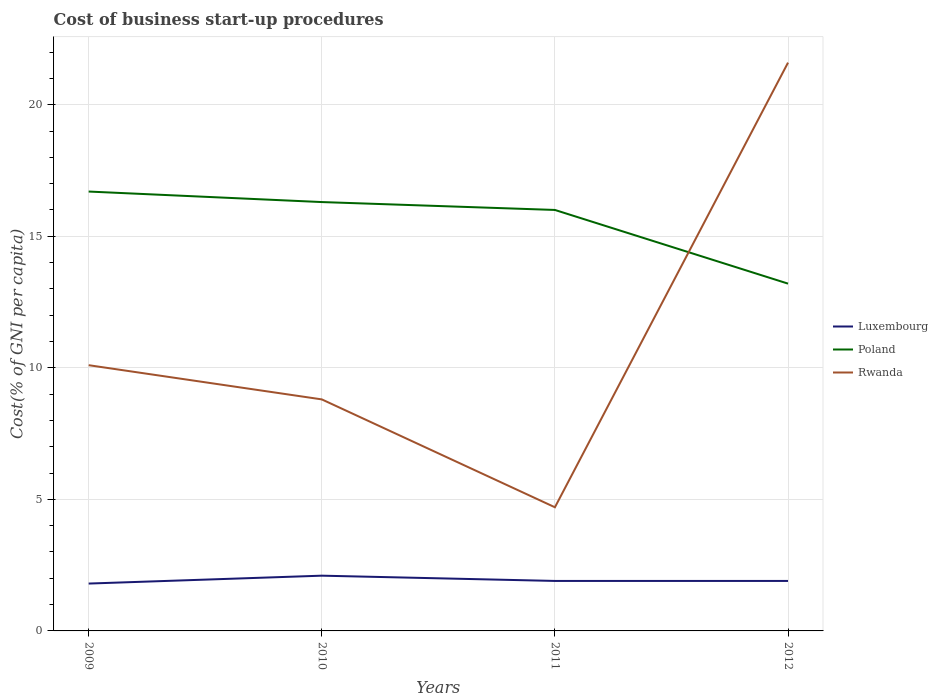How many different coloured lines are there?
Ensure brevity in your answer.  3. Is the number of lines equal to the number of legend labels?
Make the answer very short. Yes. What is the total cost of business start-up procedures in Luxembourg in the graph?
Keep it short and to the point. 0.2. What is the difference between the highest and the second highest cost of business start-up procedures in Luxembourg?
Your response must be concise. 0.3. What is the difference between the highest and the lowest cost of business start-up procedures in Poland?
Offer a terse response. 3. Is the cost of business start-up procedures in Rwanda strictly greater than the cost of business start-up procedures in Poland over the years?
Offer a very short reply. No. How many lines are there?
Give a very brief answer. 3. How many years are there in the graph?
Make the answer very short. 4. What is the difference between two consecutive major ticks on the Y-axis?
Provide a short and direct response. 5. Does the graph contain any zero values?
Offer a very short reply. No. Where does the legend appear in the graph?
Provide a succinct answer. Center right. How many legend labels are there?
Your response must be concise. 3. How are the legend labels stacked?
Keep it short and to the point. Vertical. What is the title of the graph?
Offer a very short reply. Cost of business start-up procedures. Does "Colombia" appear as one of the legend labels in the graph?
Offer a very short reply. No. What is the label or title of the X-axis?
Keep it short and to the point. Years. What is the label or title of the Y-axis?
Provide a succinct answer. Cost(% of GNI per capita). What is the Cost(% of GNI per capita) of Luxembourg in 2009?
Your answer should be very brief. 1.8. What is the Cost(% of GNI per capita) of Rwanda in 2009?
Offer a very short reply. 10.1. What is the Cost(% of GNI per capita) of Luxembourg in 2010?
Your answer should be very brief. 2.1. What is the Cost(% of GNI per capita) of Luxembourg in 2012?
Your answer should be very brief. 1.9. What is the Cost(% of GNI per capita) of Poland in 2012?
Your answer should be compact. 13.2. What is the Cost(% of GNI per capita) in Rwanda in 2012?
Keep it short and to the point. 21.6. Across all years, what is the maximum Cost(% of GNI per capita) in Rwanda?
Your answer should be compact. 21.6. Across all years, what is the minimum Cost(% of GNI per capita) in Rwanda?
Ensure brevity in your answer.  4.7. What is the total Cost(% of GNI per capita) of Poland in the graph?
Offer a very short reply. 62.2. What is the total Cost(% of GNI per capita) in Rwanda in the graph?
Provide a short and direct response. 45.2. What is the difference between the Cost(% of GNI per capita) in Luxembourg in 2009 and that in 2010?
Your answer should be compact. -0.3. What is the difference between the Cost(% of GNI per capita) of Rwanda in 2009 and that in 2010?
Provide a succinct answer. 1.3. What is the difference between the Cost(% of GNI per capita) of Poland in 2009 and that in 2011?
Your answer should be compact. 0.7. What is the difference between the Cost(% of GNI per capita) of Luxembourg in 2009 and that in 2012?
Provide a short and direct response. -0.1. What is the difference between the Cost(% of GNI per capita) of Poland in 2009 and that in 2012?
Offer a very short reply. 3.5. What is the difference between the Cost(% of GNI per capita) in Poland in 2010 and that in 2011?
Give a very brief answer. 0.3. What is the difference between the Cost(% of GNI per capita) of Rwanda in 2010 and that in 2011?
Make the answer very short. 4.1. What is the difference between the Cost(% of GNI per capita) in Luxembourg in 2010 and that in 2012?
Your answer should be compact. 0.2. What is the difference between the Cost(% of GNI per capita) of Poland in 2010 and that in 2012?
Keep it short and to the point. 3.1. What is the difference between the Cost(% of GNI per capita) of Rwanda in 2010 and that in 2012?
Offer a terse response. -12.8. What is the difference between the Cost(% of GNI per capita) in Luxembourg in 2011 and that in 2012?
Provide a short and direct response. 0. What is the difference between the Cost(% of GNI per capita) of Poland in 2011 and that in 2012?
Your response must be concise. 2.8. What is the difference between the Cost(% of GNI per capita) of Rwanda in 2011 and that in 2012?
Your answer should be compact. -16.9. What is the difference between the Cost(% of GNI per capita) of Luxembourg in 2009 and the Cost(% of GNI per capita) of Poland in 2010?
Your response must be concise. -14.5. What is the difference between the Cost(% of GNI per capita) in Luxembourg in 2009 and the Cost(% of GNI per capita) in Rwanda in 2010?
Ensure brevity in your answer.  -7. What is the difference between the Cost(% of GNI per capita) of Poland in 2009 and the Cost(% of GNI per capita) of Rwanda in 2010?
Your response must be concise. 7.9. What is the difference between the Cost(% of GNI per capita) in Luxembourg in 2009 and the Cost(% of GNI per capita) in Poland in 2011?
Keep it short and to the point. -14.2. What is the difference between the Cost(% of GNI per capita) in Luxembourg in 2009 and the Cost(% of GNI per capita) in Poland in 2012?
Your answer should be compact. -11.4. What is the difference between the Cost(% of GNI per capita) in Luxembourg in 2009 and the Cost(% of GNI per capita) in Rwanda in 2012?
Offer a terse response. -19.8. What is the difference between the Cost(% of GNI per capita) of Luxembourg in 2010 and the Cost(% of GNI per capita) of Poland in 2011?
Your answer should be very brief. -13.9. What is the difference between the Cost(% of GNI per capita) in Poland in 2010 and the Cost(% of GNI per capita) in Rwanda in 2011?
Keep it short and to the point. 11.6. What is the difference between the Cost(% of GNI per capita) in Luxembourg in 2010 and the Cost(% of GNI per capita) in Rwanda in 2012?
Your response must be concise. -19.5. What is the difference between the Cost(% of GNI per capita) of Luxembourg in 2011 and the Cost(% of GNI per capita) of Rwanda in 2012?
Make the answer very short. -19.7. What is the average Cost(% of GNI per capita) of Luxembourg per year?
Make the answer very short. 1.93. What is the average Cost(% of GNI per capita) in Poland per year?
Provide a short and direct response. 15.55. What is the average Cost(% of GNI per capita) of Rwanda per year?
Your answer should be compact. 11.3. In the year 2009, what is the difference between the Cost(% of GNI per capita) of Luxembourg and Cost(% of GNI per capita) of Poland?
Offer a terse response. -14.9. In the year 2009, what is the difference between the Cost(% of GNI per capita) in Luxembourg and Cost(% of GNI per capita) in Rwanda?
Keep it short and to the point. -8.3. In the year 2009, what is the difference between the Cost(% of GNI per capita) in Poland and Cost(% of GNI per capita) in Rwanda?
Provide a short and direct response. 6.6. In the year 2010, what is the difference between the Cost(% of GNI per capita) in Poland and Cost(% of GNI per capita) in Rwanda?
Your answer should be compact. 7.5. In the year 2011, what is the difference between the Cost(% of GNI per capita) in Luxembourg and Cost(% of GNI per capita) in Poland?
Give a very brief answer. -14.1. In the year 2011, what is the difference between the Cost(% of GNI per capita) of Luxembourg and Cost(% of GNI per capita) of Rwanda?
Provide a short and direct response. -2.8. In the year 2012, what is the difference between the Cost(% of GNI per capita) of Luxembourg and Cost(% of GNI per capita) of Poland?
Your response must be concise. -11.3. In the year 2012, what is the difference between the Cost(% of GNI per capita) of Luxembourg and Cost(% of GNI per capita) of Rwanda?
Your response must be concise. -19.7. What is the ratio of the Cost(% of GNI per capita) in Luxembourg in 2009 to that in 2010?
Offer a very short reply. 0.86. What is the ratio of the Cost(% of GNI per capita) of Poland in 2009 to that in 2010?
Keep it short and to the point. 1.02. What is the ratio of the Cost(% of GNI per capita) in Rwanda in 2009 to that in 2010?
Offer a very short reply. 1.15. What is the ratio of the Cost(% of GNI per capita) of Luxembourg in 2009 to that in 2011?
Provide a succinct answer. 0.95. What is the ratio of the Cost(% of GNI per capita) of Poland in 2009 to that in 2011?
Ensure brevity in your answer.  1.04. What is the ratio of the Cost(% of GNI per capita) of Rwanda in 2009 to that in 2011?
Your answer should be compact. 2.15. What is the ratio of the Cost(% of GNI per capita) of Luxembourg in 2009 to that in 2012?
Your answer should be compact. 0.95. What is the ratio of the Cost(% of GNI per capita) of Poland in 2009 to that in 2012?
Your answer should be very brief. 1.27. What is the ratio of the Cost(% of GNI per capita) of Rwanda in 2009 to that in 2012?
Keep it short and to the point. 0.47. What is the ratio of the Cost(% of GNI per capita) of Luxembourg in 2010 to that in 2011?
Offer a terse response. 1.11. What is the ratio of the Cost(% of GNI per capita) of Poland in 2010 to that in 2011?
Your answer should be compact. 1.02. What is the ratio of the Cost(% of GNI per capita) in Rwanda in 2010 to that in 2011?
Your answer should be compact. 1.87. What is the ratio of the Cost(% of GNI per capita) in Luxembourg in 2010 to that in 2012?
Provide a succinct answer. 1.11. What is the ratio of the Cost(% of GNI per capita) of Poland in 2010 to that in 2012?
Provide a short and direct response. 1.23. What is the ratio of the Cost(% of GNI per capita) in Rwanda in 2010 to that in 2012?
Your answer should be compact. 0.41. What is the ratio of the Cost(% of GNI per capita) in Poland in 2011 to that in 2012?
Your answer should be compact. 1.21. What is the ratio of the Cost(% of GNI per capita) in Rwanda in 2011 to that in 2012?
Make the answer very short. 0.22. What is the difference between the highest and the second highest Cost(% of GNI per capita) in Luxembourg?
Ensure brevity in your answer.  0.2. What is the difference between the highest and the second highest Cost(% of GNI per capita) in Poland?
Provide a short and direct response. 0.4. What is the difference between the highest and the lowest Cost(% of GNI per capita) of Poland?
Your answer should be very brief. 3.5. 